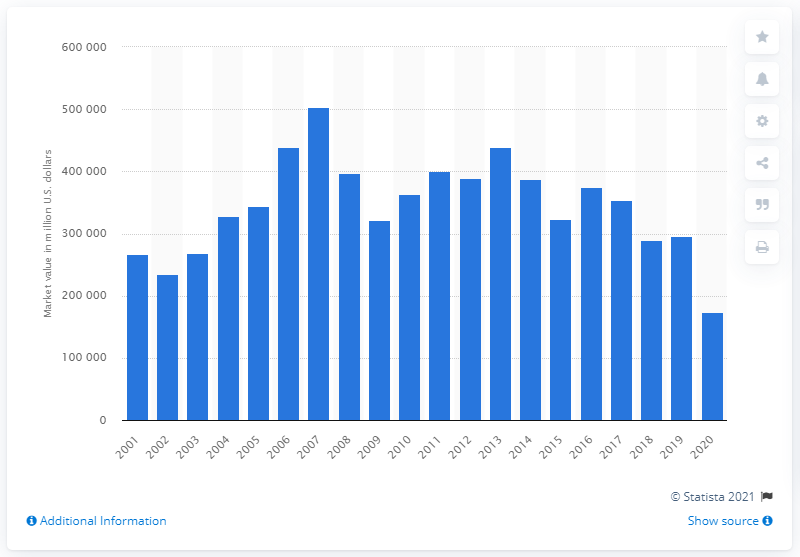Specify some key components in this picture. At the end of 2020, ExxonMobil had a market value of approximately 174,505. ExxonMobil's market value at the end of the previous year was approximately 295,431... 